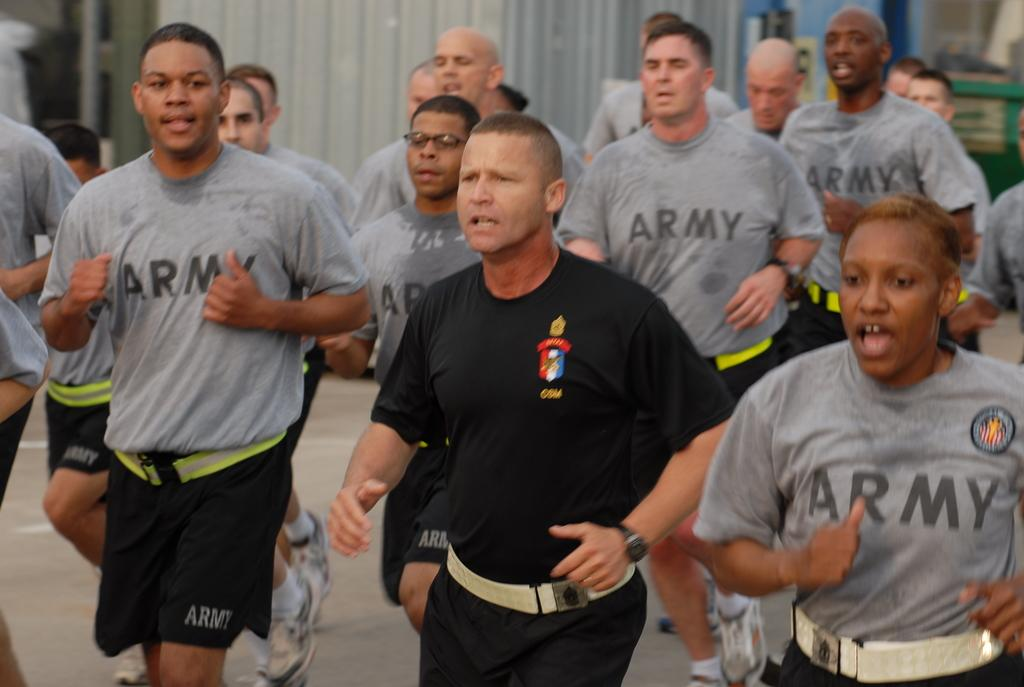What are the persons in the image doing? The persons in the image are running. What can be seen at the bottom of the image? The ground is visible at the bottom of the image. Can you see a boy wearing a stocking in the image? There is no boy or stocking mentioned in the provided facts, so we cannot determine if they are present in the image. 